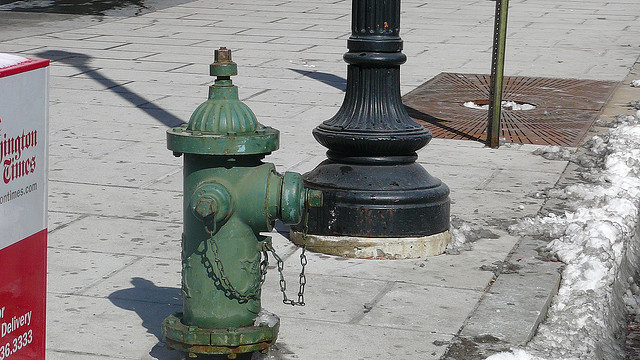Read all the text in this image. ington Times ontimes.com 36.3333 Delivery 